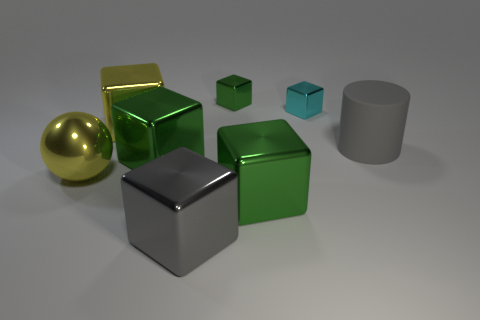Subtract all brown cylinders. How many green cubes are left? 3 Subtract all yellow cubes. How many cubes are left? 5 Subtract all yellow metallic cubes. How many cubes are left? 5 Subtract all gray cubes. Subtract all cyan spheres. How many cubes are left? 5 Add 1 tiny matte cylinders. How many objects exist? 9 Subtract all blocks. How many objects are left? 2 Add 7 cyan blocks. How many cyan blocks are left? 8 Add 6 small cyan cubes. How many small cyan cubes exist? 7 Subtract 0 gray balls. How many objects are left? 8 Subtract all yellow cylinders. Subtract all small green cubes. How many objects are left? 7 